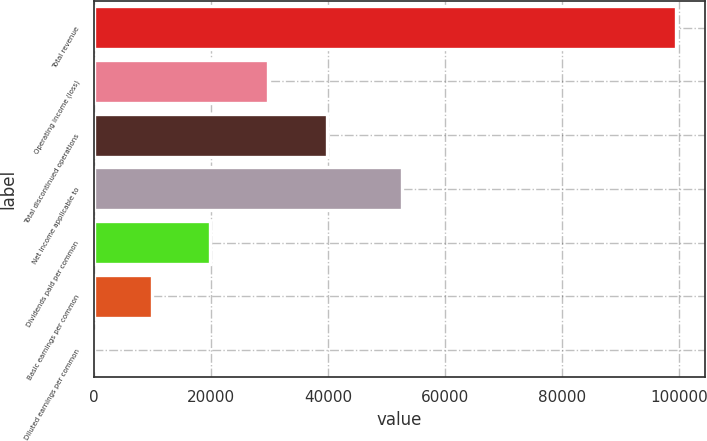Convert chart. <chart><loc_0><loc_0><loc_500><loc_500><bar_chart><fcel>Total revenue<fcel>Operating income (loss)<fcel>Total discontinued operations<fcel>Net income applicable to<fcel>Dividends paid per common<fcel>Basic earnings per common<fcel>Diluted earnings per common<nl><fcel>99436<fcel>29831.1<fcel>39774.6<fcel>52605<fcel>19887.5<fcel>9943.94<fcel>0.38<nl></chart> 